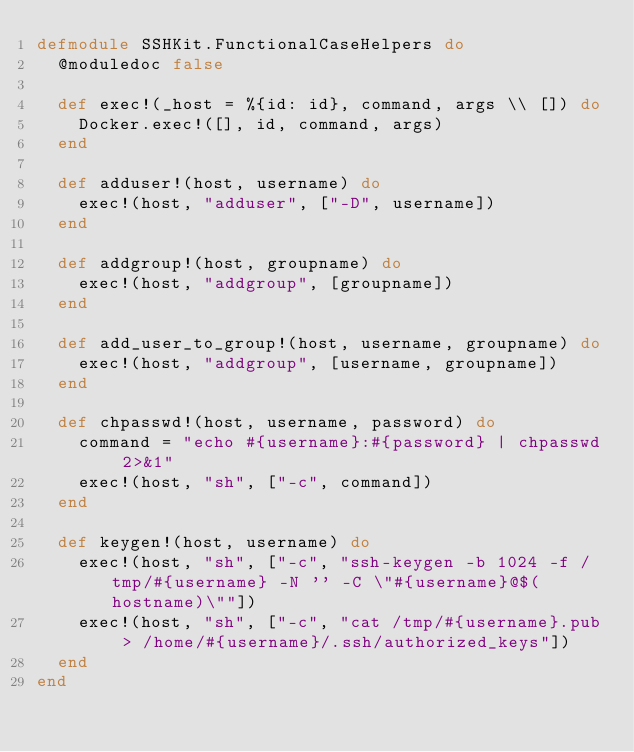<code> <loc_0><loc_0><loc_500><loc_500><_Elixir_>defmodule SSHKit.FunctionalCaseHelpers do
  @moduledoc false

  def exec!(_host = %{id: id}, command, args \\ []) do
    Docker.exec!([], id, command, args)
  end

  def adduser!(host, username) do
    exec!(host, "adduser", ["-D", username])
  end

  def addgroup!(host, groupname) do
    exec!(host, "addgroup", [groupname])
  end

  def add_user_to_group!(host, username, groupname) do
    exec!(host, "addgroup", [username, groupname])
  end

  def chpasswd!(host, username, password) do
    command = "echo #{username}:#{password} | chpasswd 2>&1"
    exec!(host, "sh", ["-c", command])
  end

  def keygen!(host, username) do
    exec!(host, "sh", ["-c", "ssh-keygen -b 1024 -f /tmp/#{username} -N '' -C \"#{username}@$(hostname)\""])
    exec!(host, "sh", ["-c", "cat /tmp/#{username}.pub > /home/#{username}/.ssh/authorized_keys"])
  end
end
</code> 